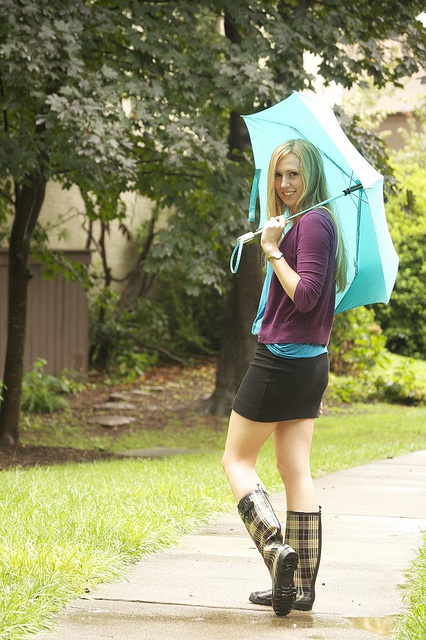Describe the objects in this image and their specific colors. I can see people in gray, black, ivory, and tan tones and umbrella in gray, lightblue, cyan, and turquoise tones in this image. 